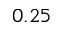<formula> <loc_0><loc_0><loc_500><loc_500>0 . 2 5</formula> 